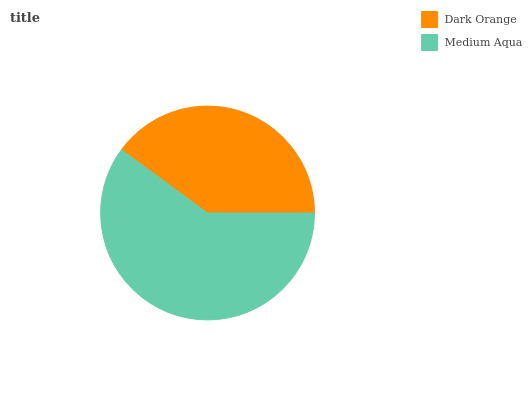Is Dark Orange the minimum?
Answer yes or no. Yes. Is Medium Aqua the maximum?
Answer yes or no. Yes. Is Medium Aqua the minimum?
Answer yes or no. No. Is Medium Aqua greater than Dark Orange?
Answer yes or no. Yes. Is Dark Orange less than Medium Aqua?
Answer yes or no. Yes. Is Dark Orange greater than Medium Aqua?
Answer yes or no. No. Is Medium Aqua less than Dark Orange?
Answer yes or no. No. Is Medium Aqua the high median?
Answer yes or no. Yes. Is Dark Orange the low median?
Answer yes or no. Yes. Is Dark Orange the high median?
Answer yes or no. No. Is Medium Aqua the low median?
Answer yes or no. No. 